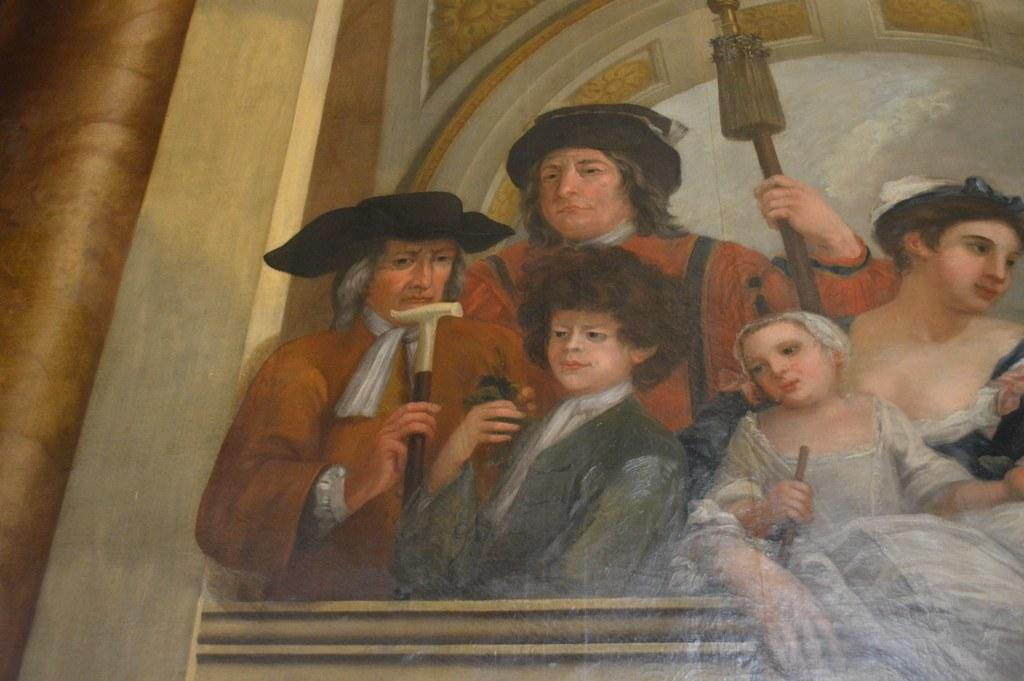What is the main subject of the image? The main subject of the image is a painting. Are there any people in the image? Yes, there is a group of persons standing in the image. Can you describe the man in the image? The man is holding an object in the image. What type of trick is the dad performing with the box in the image? There is no dad or box present in the image, so no such trick can be observed. 